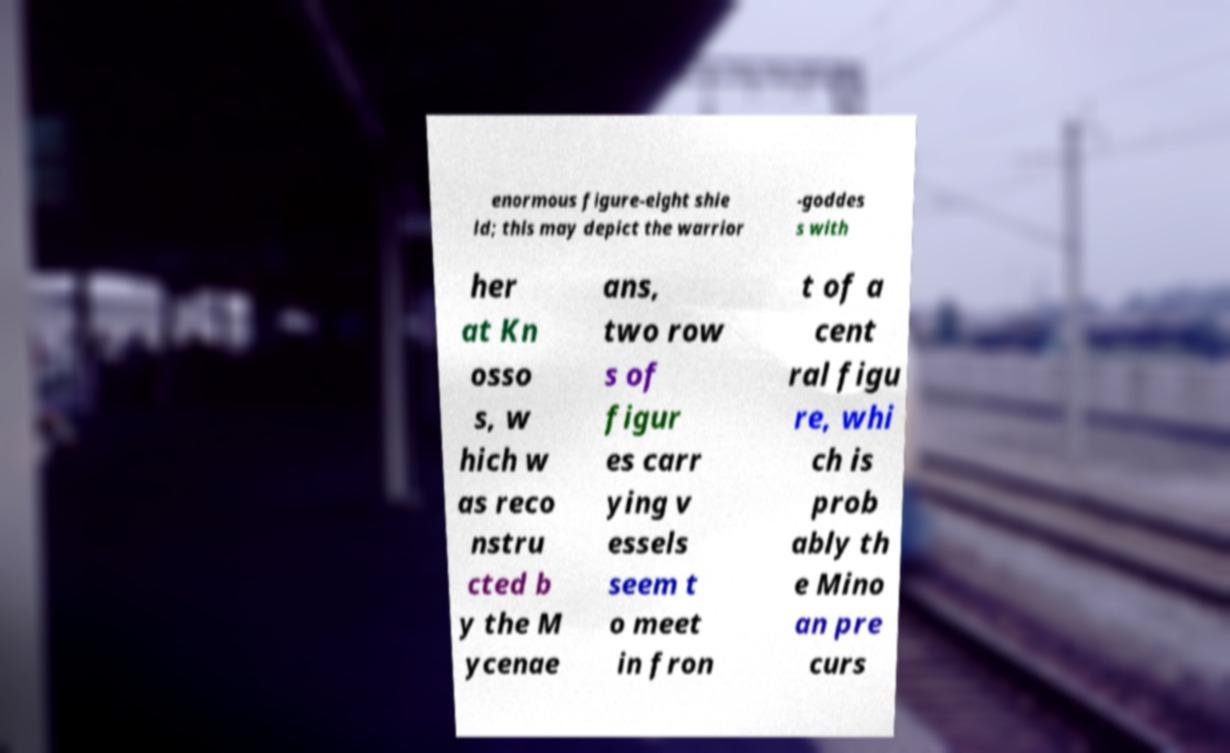What messages or text are displayed in this image? I need them in a readable, typed format. enormous figure-eight shie ld; this may depict the warrior -goddes s with her at Kn osso s, w hich w as reco nstru cted b y the M ycenae ans, two row s of figur es carr ying v essels seem t o meet in fron t of a cent ral figu re, whi ch is prob ably th e Mino an pre curs 